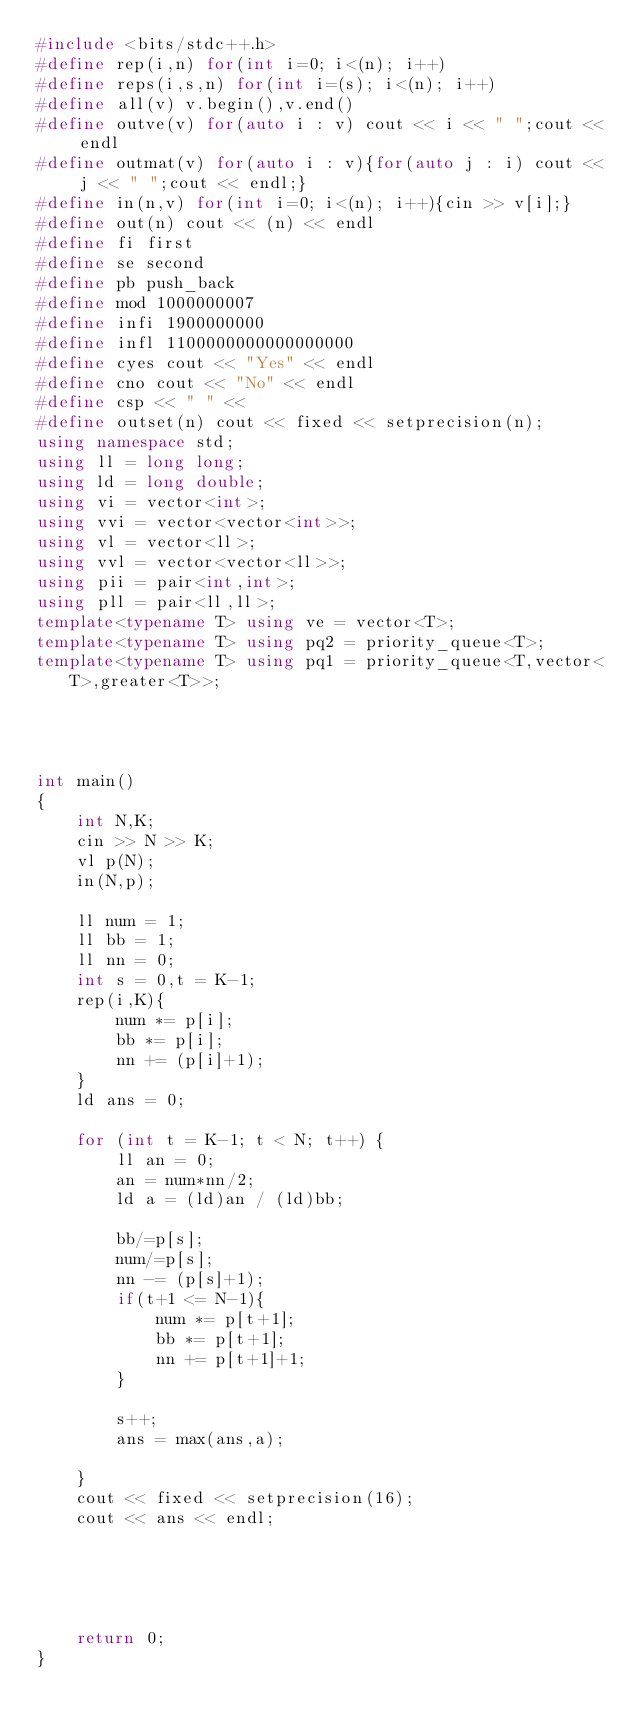<code> <loc_0><loc_0><loc_500><loc_500><_C++_>#include <bits/stdc++.h>
#define rep(i,n) for(int i=0; i<(n); i++)
#define reps(i,s,n) for(int i=(s); i<(n); i++)
#define all(v) v.begin(),v.end()
#define outve(v) for(auto i : v) cout << i << " ";cout << endl
#define outmat(v) for(auto i : v){for(auto j : i) cout << j << " ";cout << endl;}
#define in(n,v) for(int i=0; i<(n); i++){cin >> v[i];}
#define out(n) cout << (n) << endl
#define fi first
#define se second
#define pb push_back
#define mod 1000000007
#define infi 1900000000
#define infl 1100000000000000000
#define cyes cout << "Yes" << endl
#define cno cout << "No" << endl
#define csp << " " <<
#define outset(n) cout << fixed << setprecision(n);
using namespace std;
using ll = long long;
using ld = long double;
using vi = vector<int>;
using vvi = vector<vector<int>>;
using vl = vector<ll>;
using vvl = vector<vector<ll>>;
using pii = pair<int,int>;
using pll = pair<ll,ll>;
template<typename T> using ve = vector<T>;
template<typename T> using pq2 = priority_queue<T>;
template<typename T> using pq1 = priority_queue<T,vector<T>,greater<T>>;




int main()
{
    int N,K;
    cin >> N >> K;
    vl p(N);
    in(N,p);
    
    ll num = 1;
    ll bb = 1;
    ll nn = 0;
    int s = 0,t = K-1;
    rep(i,K){
        num *= p[i];
        bb *= p[i];
        nn += (p[i]+1);
    }
    ld ans = 0;
    
    for (int t = K-1; t < N; t++) {
        ll an = 0;
        an = num*nn/2;
        ld a = (ld)an / (ld)bb;
        
        bb/=p[s];
        num/=p[s];
        nn -= (p[s]+1);
        if(t+1 <= N-1){
            num *= p[t+1];
            bb *= p[t+1];
            nn += p[t+1]+1;
        }
        
        s++;
        ans = max(ans,a);
        
    }
    cout << fixed << setprecision(16);
    cout << ans << endl;
    
    
    
    

    return 0;
}
</code> 